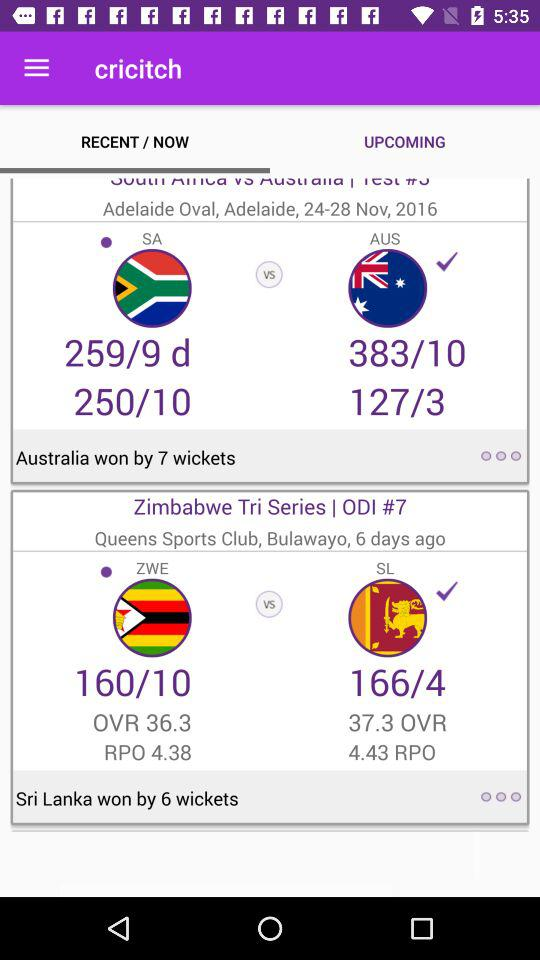Which tab is selected? The selected tab is "RECENT / NOW". 